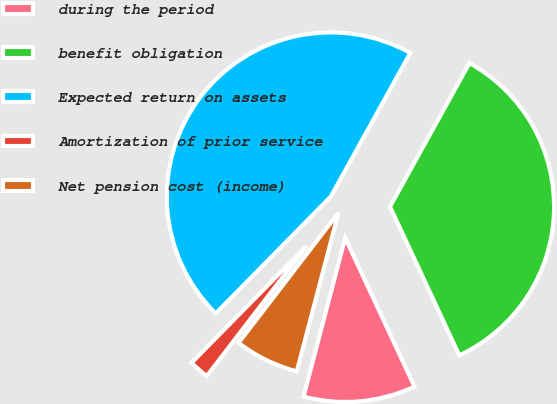Convert chart. <chart><loc_0><loc_0><loc_500><loc_500><pie_chart><fcel>during the period<fcel>benefit obligation<fcel>Expected return on assets<fcel>Amortization of prior service<fcel>Net pension cost (income)<nl><fcel>11.03%<fcel>35.01%<fcel>45.66%<fcel>1.96%<fcel>6.33%<nl></chart> 